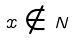<formula> <loc_0><loc_0><loc_500><loc_500>x \notin N</formula> 